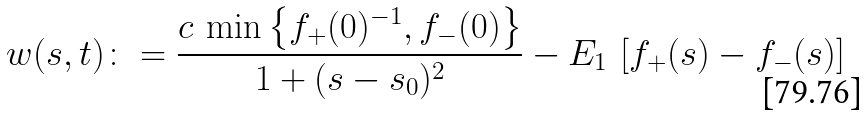Convert formula to latex. <formula><loc_0><loc_0><loc_500><loc_500>w ( s , t ) \colon = \frac { c \, \min \left \{ f _ { + } ( 0 ) ^ { - 1 } , f _ { - } ( 0 ) \right \} } { 1 + ( s - s _ { 0 } ) ^ { 2 } } - E _ { 1 } \, \left [ f _ { + } ( s ) - f _ { - } ( s ) \right ]</formula> 